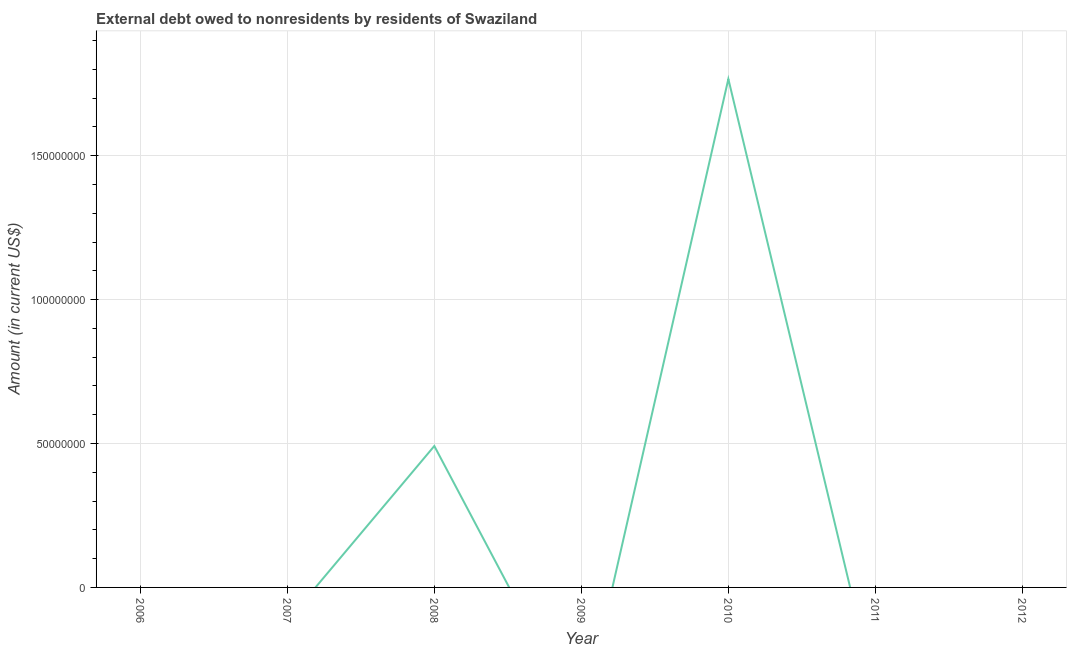What is the debt in 2008?
Keep it short and to the point. 4.91e+07. Across all years, what is the maximum debt?
Your response must be concise. 1.77e+08. What is the sum of the debt?
Your answer should be compact. 2.26e+08. What is the average debt per year?
Offer a very short reply. 3.23e+07. What is the median debt?
Your answer should be very brief. 0. In how many years, is the debt greater than 100000000 US$?
Ensure brevity in your answer.  1. What is the difference between the highest and the lowest debt?
Make the answer very short. 1.77e+08. Does the debt monotonically increase over the years?
Make the answer very short. No. How many years are there in the graph?
Provide a succinct answer. 7. What is the difference between two consecutive major ticks on the Y-axis?
Offer a terse response. 5.00e+07. Are the values on the major ticks of Y-axis written in scientific E-notation?
Provide a short and direct response. No. Does the graph contain any zero values?
Keep it short and to the point. Yes. Does the graph contain grids?
Offer a terse response. Yes. What is the title of the graph?
Make the answer very short. External debt owed to nonresidents by residents of Swaziland. What is the label or title of the Y-axis?
Offer a very short reply. Amount (in current US$). What is the Amount (in current US$) of 2006?
Offer a very short reply. 0. What is the Amount (in current US$) of 2007?
Make the answer very short. 0. What is the Amount (in current US$) in 2008?
Give a very brief answer. 4.91e+07. What is the Amount (in current US$) of 2010?
Make the answer very short. 1.77e+08. What is the Amount (in current US$) in 2012?
Give a very brief answer. 0. What is the difference between the Amount (in current US$) in 2008 and 2010?
Provide a short and direct response. -1.28e+08. What is the ratio of the Amount (in current US$) in 2008 to that in 2010?
Make the answer very short. 0.28. 